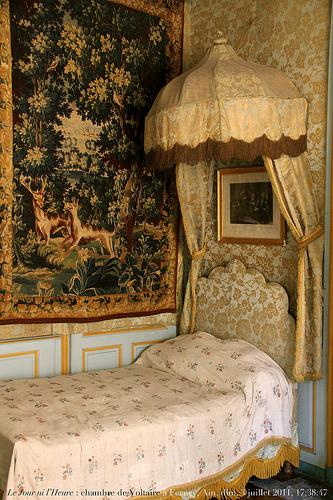Which part of the image seems to have the most complex pattern? The heavy gold tapestry canopy has a complex pattern with decorative features and tassled tiebacks. Based on the descriptions, describe the bed in the image. It is a single bed with a silken cloth yellow headboard with flowers, a floral bedspread, mustard yellow tassels on the bed skirt, and a heavy gold tapestry canopy. Mention a furniture object and its observed specification in the image. There is a hardwood floor with a small visible section. What kind of sentiment might the image evoke? The image may evoke a nostalgic, antique, and cozy sentiment. Mention a unique combination of colors found on an object in the image. Red and blue flowers on the bedspread. Discuss the theme of the textiles in the image. There is a prominent use of floral patterns, embroidery featuring deer, and gold accents for a rich, ornamented look. Identify any animal representation in the image. There is a picture of a buck on the tapestry and an embroidery of two deer. What is the prominent feature above the bed? A decorative feature with a silver-framed photo containing people and a picture of a buck on a tapestry. In three words, describe the wall in the image. Yellow, white, wainscoating. List all the colors mentioned in the image. Silver, yellow, white, mustard yellow, gold, cream, red, and blue. 